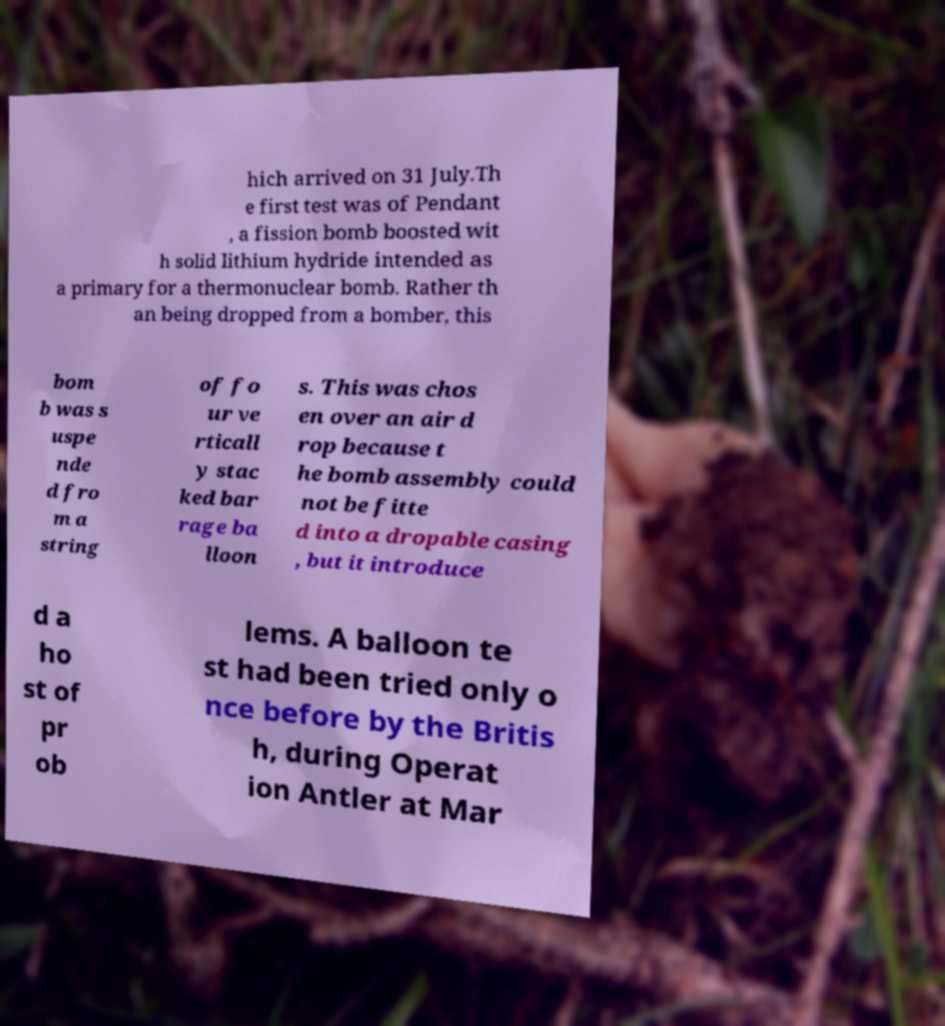For documentation purposes, I need the text within this image transcribed. Could you provide that? hich arrived on 31 July.Th e first test was of Pendant , a fission bomb boosted wit h solid lithium hydride intended as a primary for a thermonuclear bomb. Rather th an being dropped from a bomber, this bom b was s uspe nde d fro m a string of fo ur ve rticall y stac ked bar rage ba lloon s. This was chos en over an air d rop because t he bomb assembly could not be fitte d into a dropable casing , but it introduce d a ho st of pr ob lems. A balloon te st had been tried only o nce before by the Britis h, during Operat ion Antler at Mar 